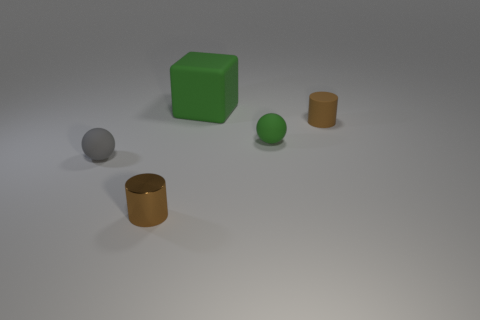Is the color of the tiny cylinder that is on the right side of the tiny metallic object the same as the tiny shiny cylinder? yes 